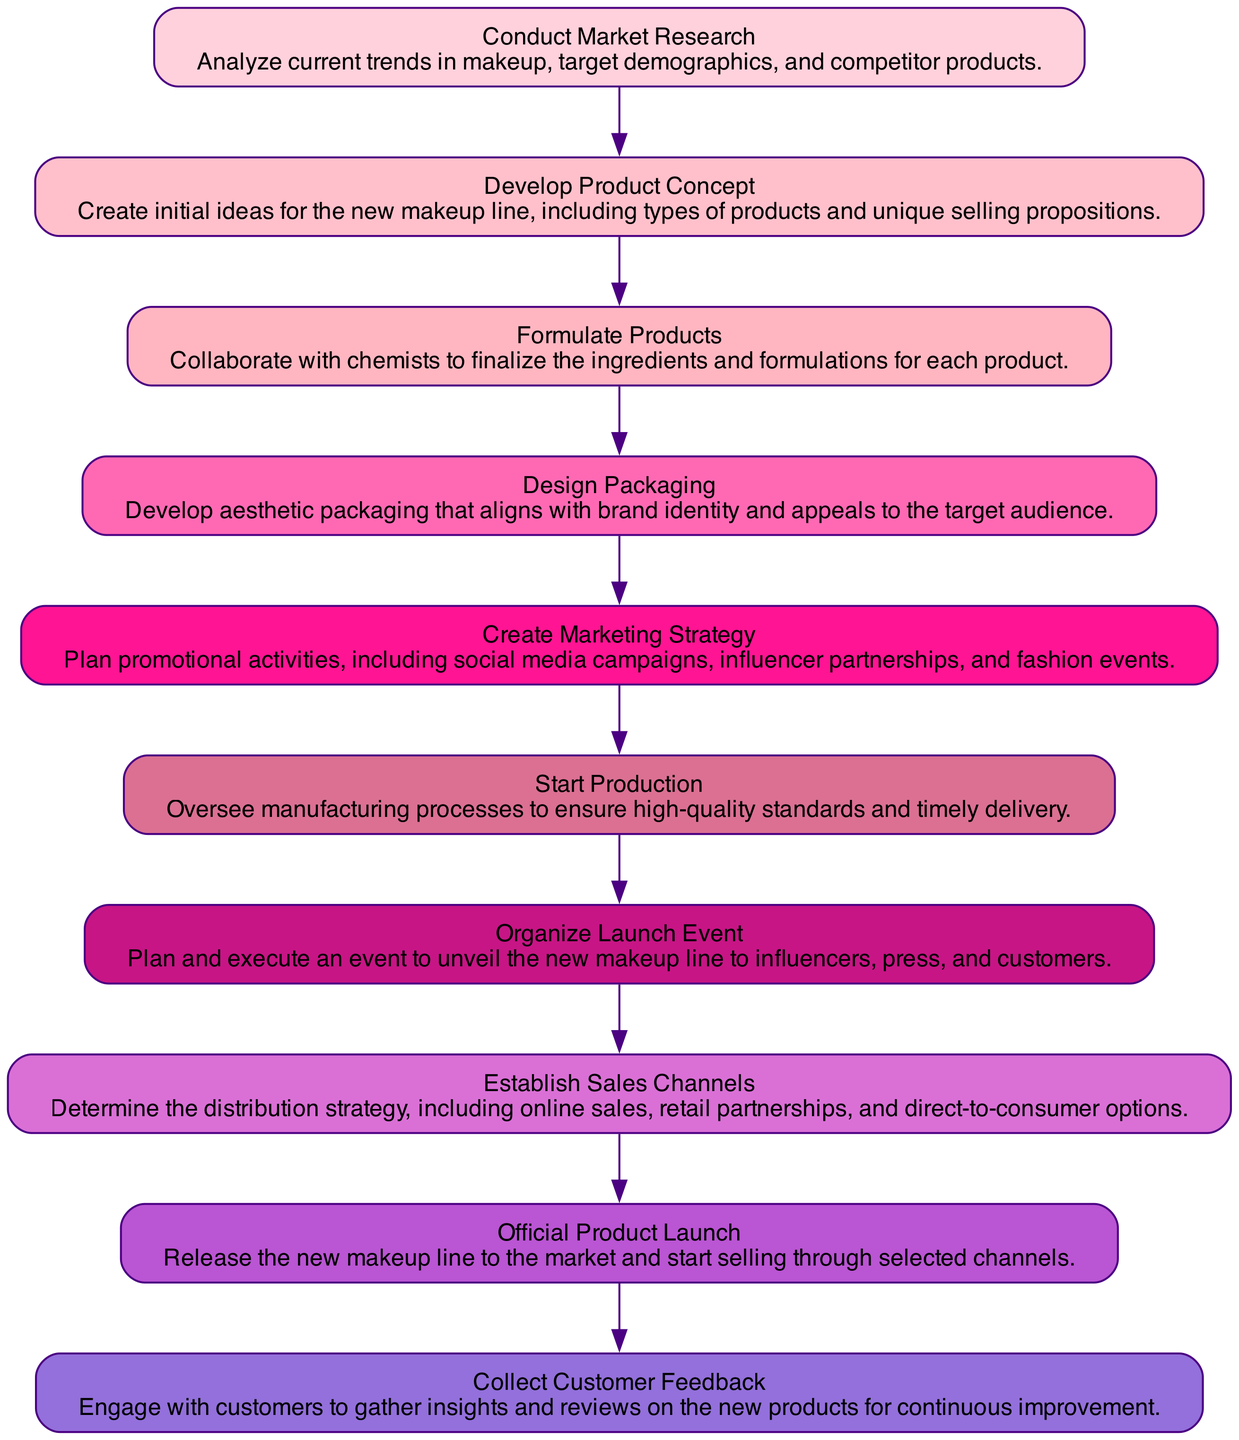What is the first step in the product launch process? The diagram starts with the node "Conduct Market Research," which indicates that this is the first step in the product launch process.
Answer: Conduct Market Research How many nodes are present in the diagram? By counting the nodes listed in the diagram, we see there are ten distinct steps involved in the product launch process.
Answer: 10 What is the relationship between "Develop Product Concept" and "Formulate Products"? In the directed graph, there is an arrow pointing from "Develop Product Concept" to "Formulate Products," indicating that product concept development leads directly to the formulation of the products.
Answer: Develop Product Concept → Formulate Products What step follows "Design Packaging"? The diagram shows that "Design Packaging" is followed by "Create Marketing Strategy," indicating that after packaging has been designed, the next step is to create a marketing strategy.
Answer: Create Marketing Strategy Which step is directly before "Official Product Launch"? According to the flow in the diagram, the step directly before "Official Product Launch" is "Establish Sales Channels," showing that setting up sales channels occurs right before launching the product.
Answer: Establish Sales Channels How many steps are between "Start Production" and "Collect Customer Feedback"? Counting the steps from "Start Production" to "Collect Customer Feedback," we see there are three nodes which represent the steps: "Organize Launch Event," "Official Product Launch," and "Launch Event." Therefore, there are three steps in between.
Answer: 3 Which step involves collaboration with chemists? The node labeled "Formulate Products" specifies that this step involves collaboration with chemists to finalize the ingredients and formulations for the products in the makeup line.
Answer: Formulate Products What is the last step in the product launch process? The final node in the directed graph is "Collect Customer Feedback," which indicates that after launching the product, the process includes gathering insights and reviews from customers.
Answer: Collect Customer Feedback What is the primary focus of the "Create Marketing Strategy" step? The description of "Create Marketing Strategy" mentions planning promotional activities like social media campaigns and influencer partnerships, which indicates that its primary focus is on marketing activities.
Answer: Plan promotional activities What is the color of the node for "Design Packaging"? Each node in the diagram has a specific color assigned to it. The node labeled "Design Packaging" is colored with the color corresponding to its order in the list, primarily represented in a light pastel pink shade.
Answer: Light pastel pink 